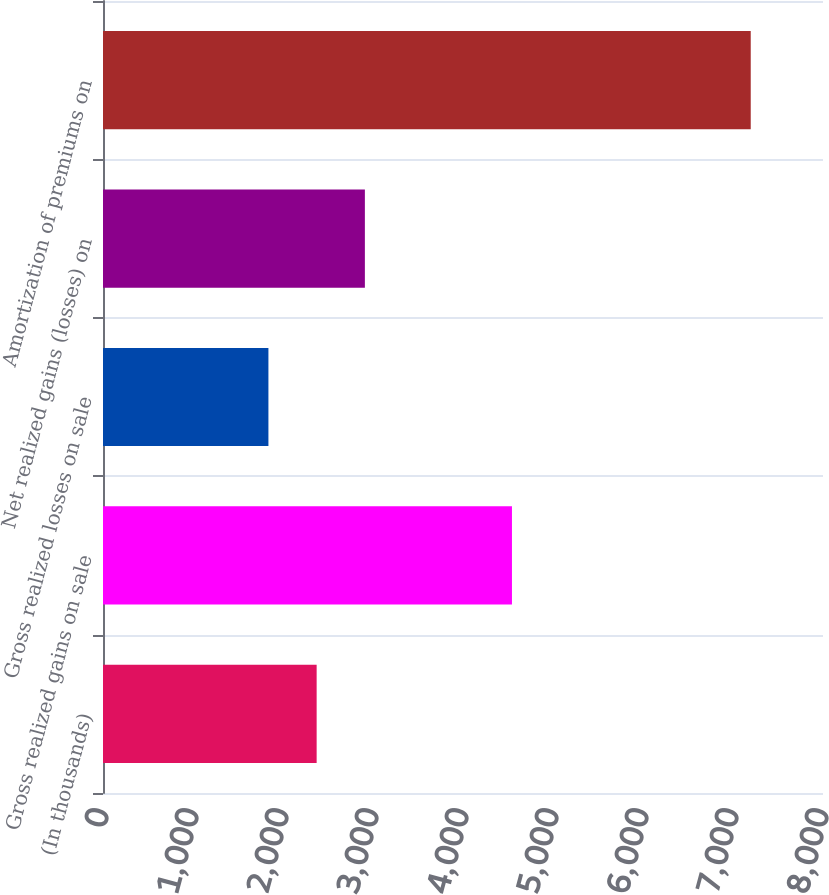Convert chart to OTSL. <chart><loc_0><loc_0><loc_500><loc_500><bar_chart><fcel>(In thousands)<fcel>Gross realized gains on sale<fcel>Gross realized losses on sale<fcel>Net realized gains (losses) on<fcel>Amortization of premiums on<nl><fcel>2373.9<fcel>4544<fcel>1838<fcel>2909.8<fcel>7197<nl></chart> 